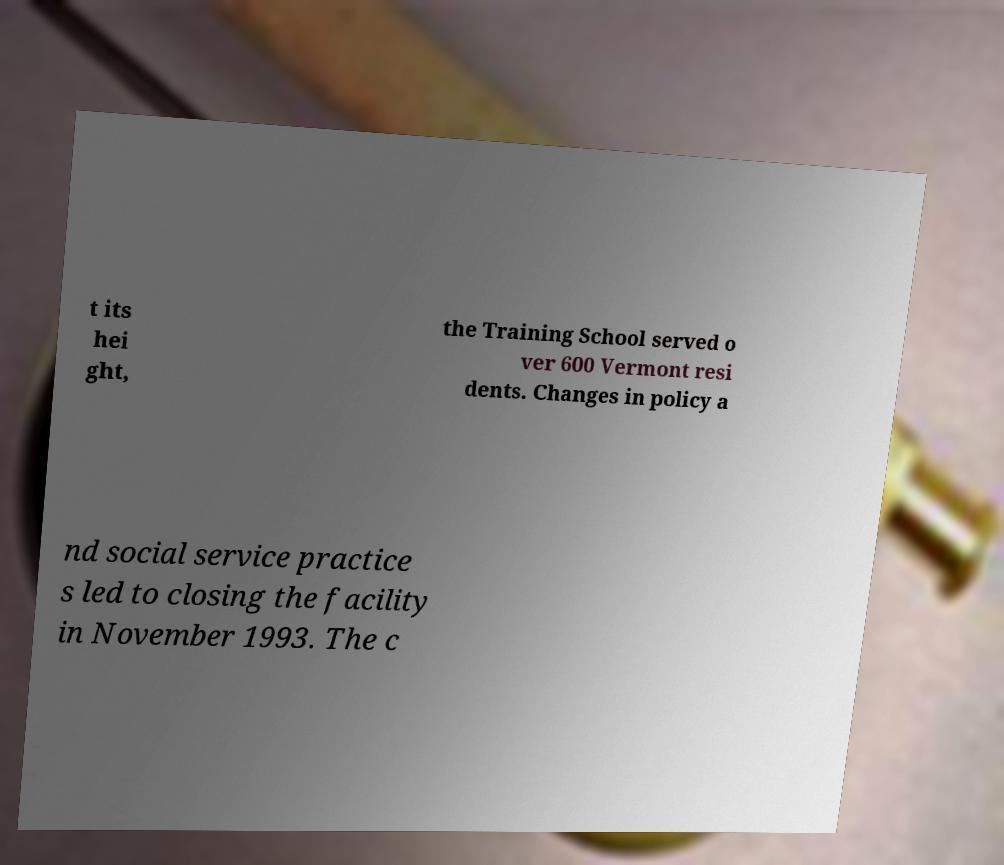There's text embedded in this image that I need extracted. Can you transcribe it verbatim? t its hei ght, the Training School served o ver 600 Vermont resi dents. Changes in policy a nd social service practice s led to closing the facility in November 1993. The c 